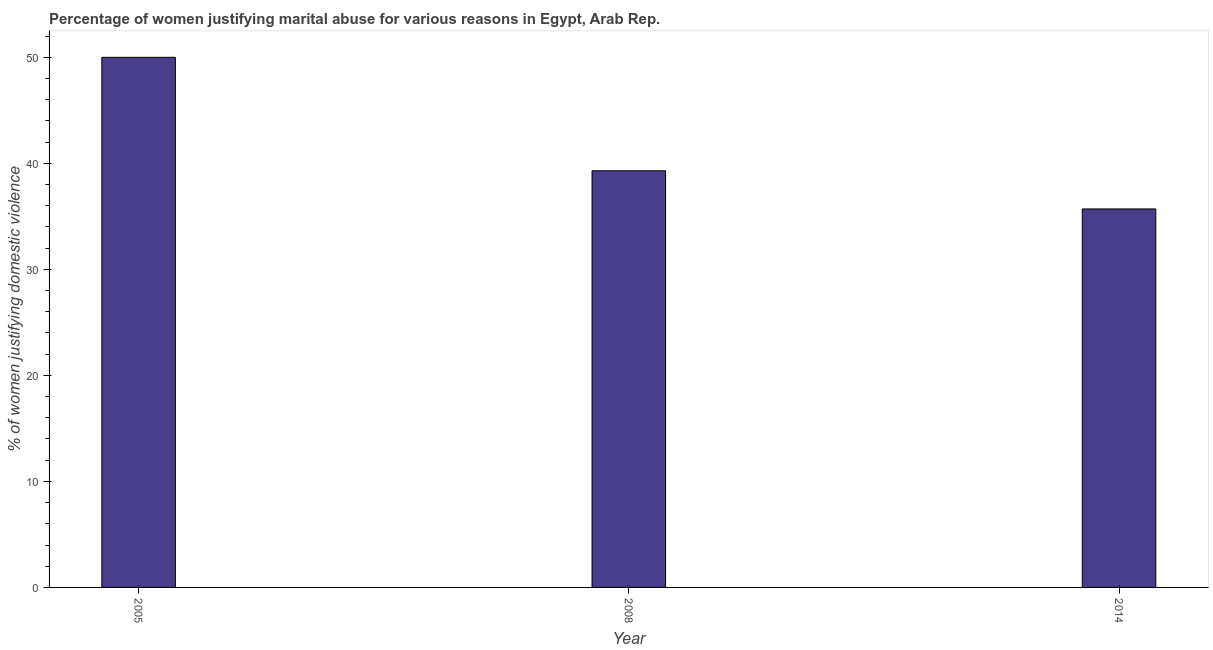Does the graph contain any zero values?
Your answer should be compact. No. Does the graph contain grids?
Provide a short and direct response. No. What is the title of the graph?
Ensure brevity in your answer.  Percentage of women justifying marital abuse for various reasons in Egypt, Arab Rep. What is the label or title of the Y-axis?
Your answer should be compact. % of women justifying domestic violence. Across all years, what is the minimum percentage of women justifying marital abuse?
Provide a short and direct response. 35.7. In which year was the percentage of women justifying marital abuse minimum?
Make the answer very short. 2014. What is the sum of the percentage of women justifying marital abuse?
Ensure brevity in your answer.  125. What is the difference between the percentage of women justifying marital abuse in 2005 and 2014?
Give a very brief answer. 14.3. What is the average percentage of women justifying marital abuse per year?
Keep it short and to the point. 41.67. What is the median percentage of women justifying marital abuse?
Ensure brevity in your answer.  39.3. Do a majority of the years between 2014 and 2005 (inclusive) have percentage of women justifying marital abuse greater than 50 %?
Give a very brief answer. Yes. What is the ratio of the percentage of women justifying marital abuse in 2008 to that in 2014?
Your answer should be compact. 1.1. Is the difference between the percentage of women justifying marital abuse in 2005 and 2008 greater than the difference between any two years?
Provide a short and direct response. No. In how many years, is the percentage of women justifying marital abuse greater than the average percentage of women justifying marital abuse taken over all years?
Keep it short and to the point. 1. Are all the bars in the graph horizontal?
Keep it short and to the point. No. Are the values on the major ticks of Y-axis written in scientific E-notation?
Offer a very short reply. No. What is the % of women justifying domestic violence of 2008?
Your answer should be very brief. 39.3. What is the % of women justifying domestic violence in 2014?
Provide a succinct answer. 35.7. What is the difference between the % of women justifying domestic violence in 2005 and 2014?
Ensure brevity in your answer.  14.3. What is the difference between the % of women justifying domestic violence in 2008 and 2014?
Ensure brevity in your answer.  3.6. What is the ratio of the % of women justifying domestic violence in 2005 to that in 2008?
Make the answer very short. 1.27. What is the ratio of the % of women justifying domestic violence in 2005 to that in 2014?
Your answer should be very brief. 1.4. What is the ratio of the % of women justifying domestic violence in 2008 to that in 2014?
Your response must be concise. 1.1. 